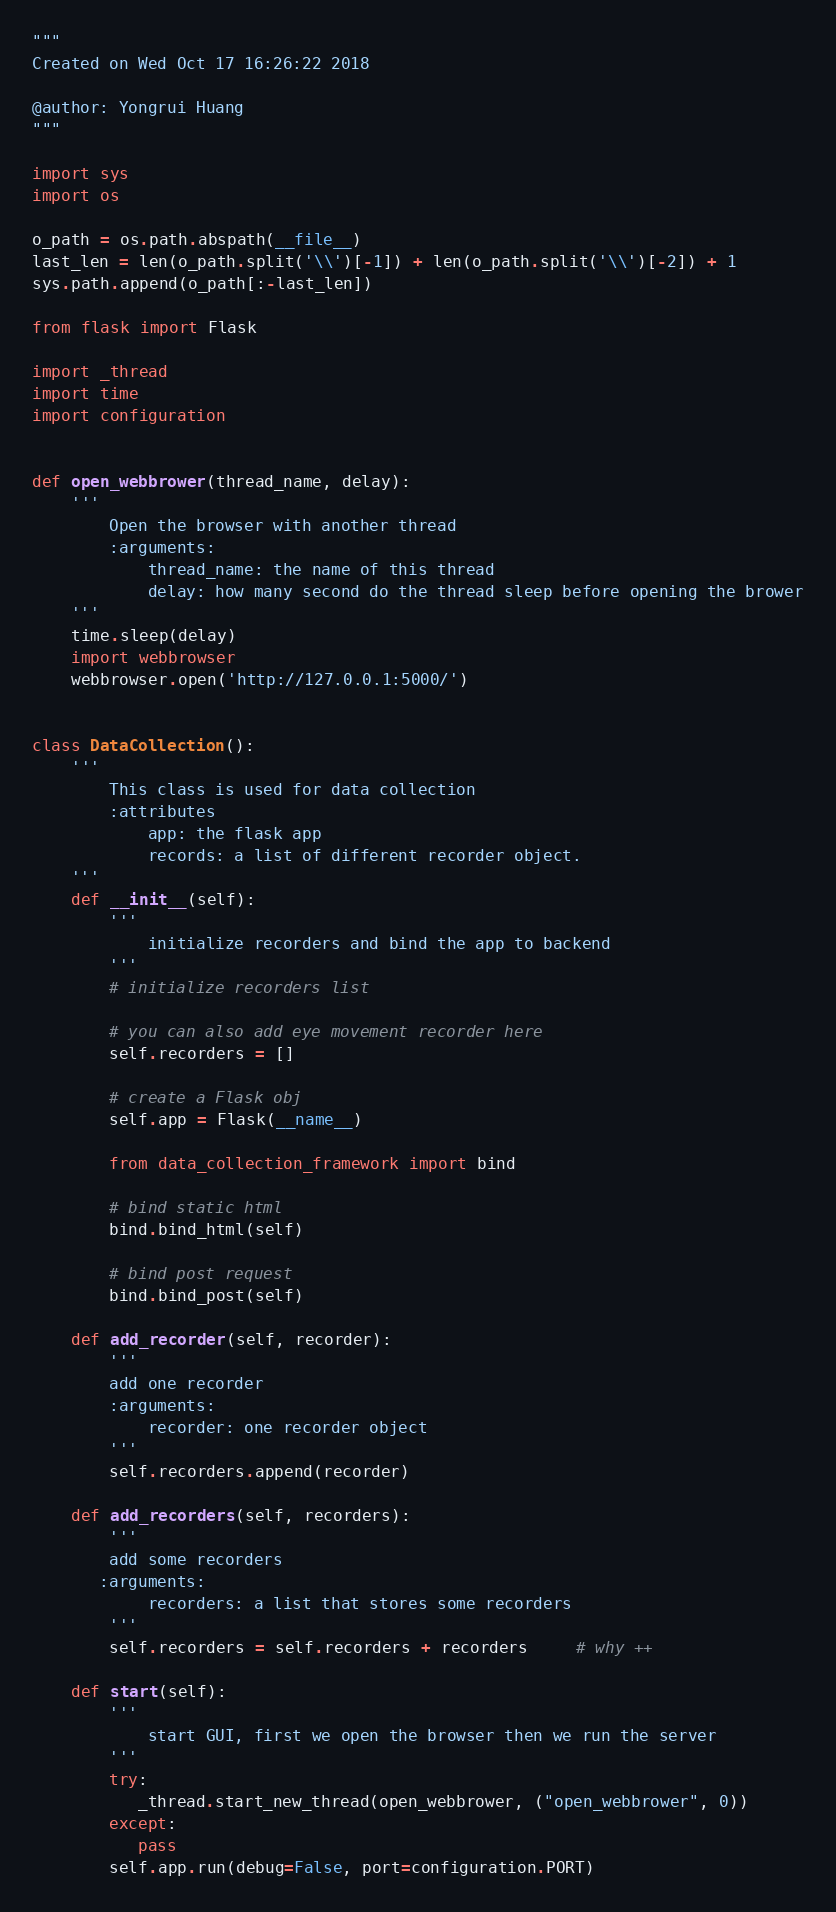<code> <loc_0><loc_0><loc_500><loc_500><_Python_>"""
Created on Wed Oct 17 16:26:22 2018

@author: Yongrui Huang
"""

import sys
import os

o_path = os.path.abspath(__file__)
last_len = len(o_path.split('\\')[-1]) + len(o_path.split('\\')[-2]) + 1
sys.path.append(o_path[:-last_len])

from flask import Flask

import _thread
import time
import configuration


def open_webbrower(thread_name, delay):
    '''
        Open the browser with another thread
        :arguments:
            thread_name: the name of this thread
            delay: how many second do the thread sleep before opening the brower
    '''
    time.sleep(delay)
    import webbrowser
    webbrowser.open('http://127.0.0.1:5000/')
    

class DataCollection():
    '''
        This class is used for data collection
        :attributes
            app: the flask app
            records: a list of different recorder object.
    '''
    def __init__(self):
        '''
            initialize recorders and bind the app to backend
        '''
        # initialize recorders list

        # you can also add eye movement recorder here
        self.recorders = []
        
        # create a Flask obj
        self.app = Flask(__name__)
        
        from data_collection_framework import bind

        # bind static html
        bind.bind_html(self)
        
        # bind post request
        bind.bind_post(self)   
        
    def add_recorder(self, recorder):
        '''
        add one recorder
        :arguments:
            recorder: one recorder object
        '''
        self.recorders.append(recorder)
        
    def add_recorders(self, recorders):
        '''
        add some recorders
       :arguments:
            recorders: a list that stores some recorders
        '''
        self.recorders = self.recorders + recorders     # why ++
        
    def start(self):
        '''
            start GUI, first we open the browser then we run the server
        '''
        try:
           _thread.start_new_thread(open_webbrower, ("open_webbrower", 0))
        except:
           pass  
        self.app.run(debug=False, port=configuration.PORT)
</code> 